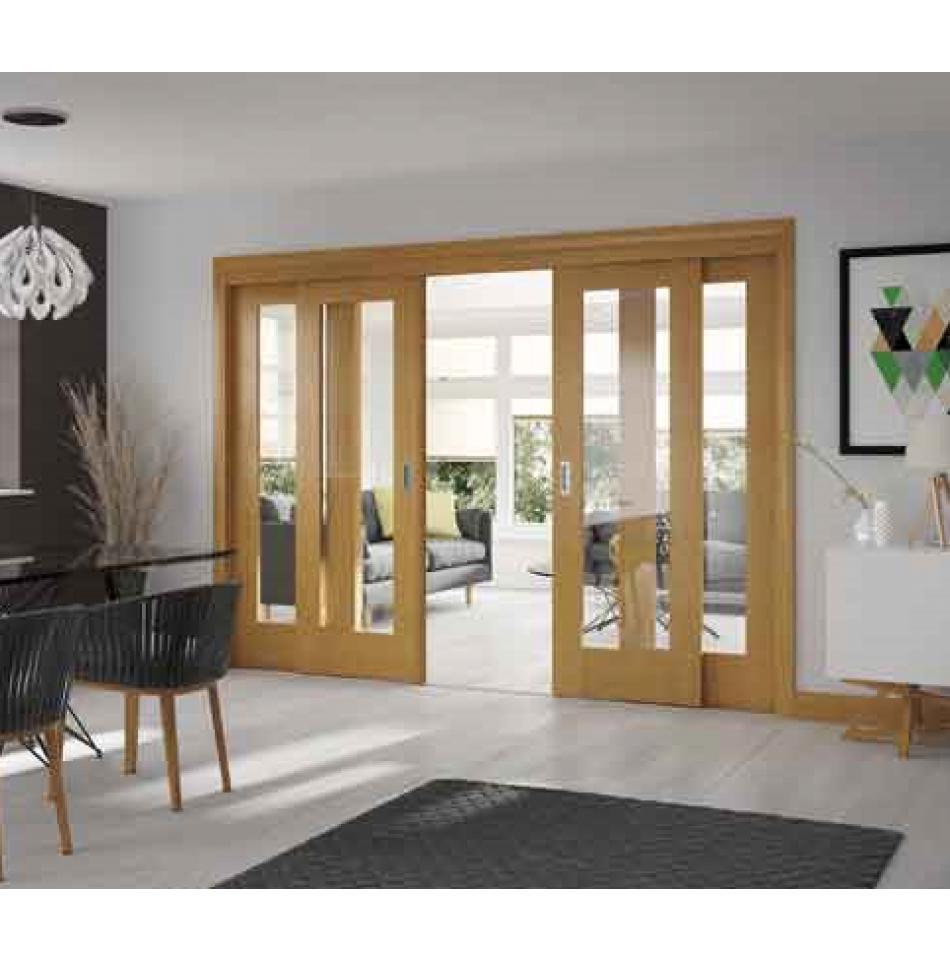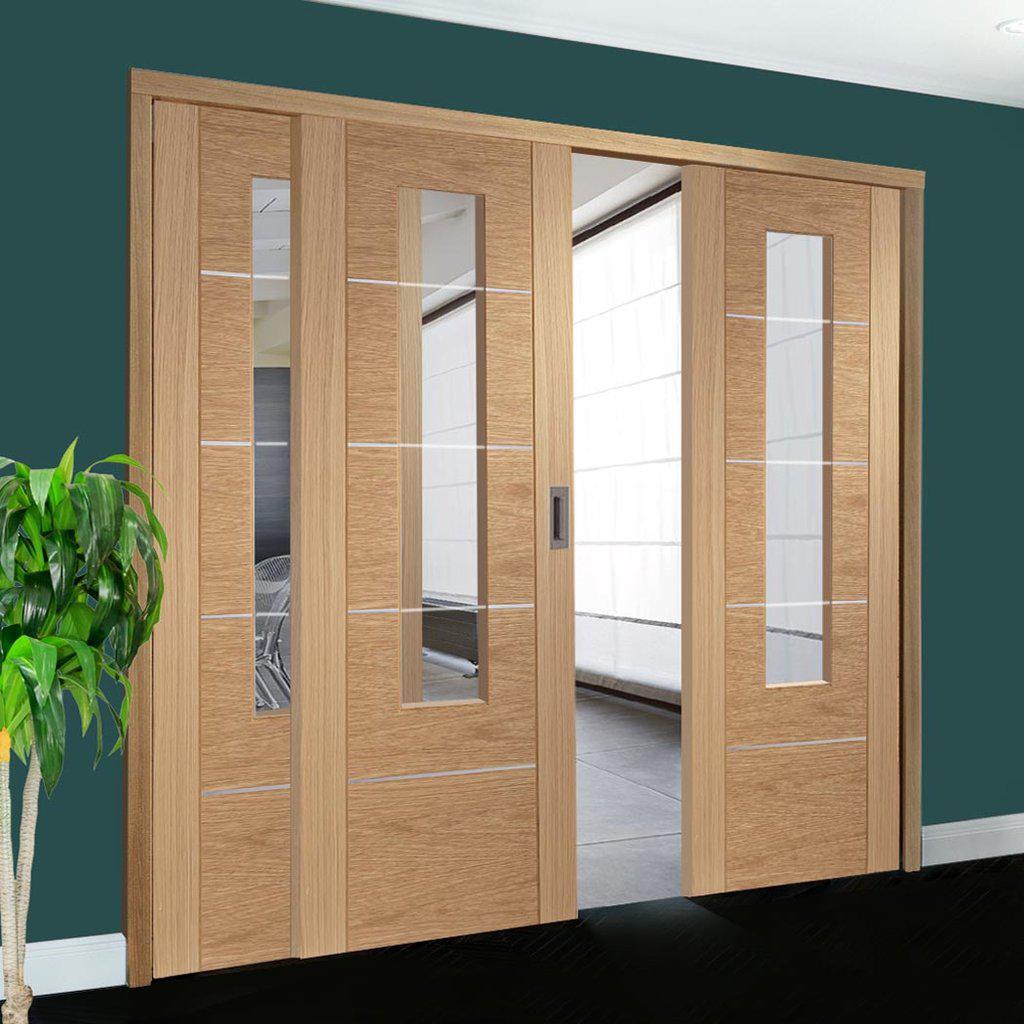The first image is the image on the left, the second image is the image on the right. Given the left and right images, does the statement "There are two chairs in the image on the left." hold true? Answer yes or no. Yes. The first image is the image on the left, the second image is the image on the right. For the images shown, is this caption "One image shows wooden sliding doors with overlapping semi-circle designs on them." true? Answer yes or no. No. 